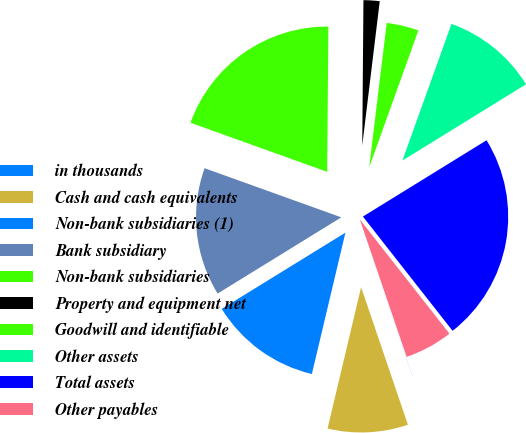Convert chart to OTSL. <chart><loc_0><loc_0><loc_500><loc_500><pie_chart><fcel>in thousands<fcel>Cash and cash equivalents<fcel>Non-bank subsidiaries (1)<fcel>Bank subsidiary<fcel>Non-bank subsidiaries<fcel>Property and equipment net<fcel>Goodwill and identifiable<fcel>Other assets<fcel>Total assets<fcel>Other payables<nl><fcel>0.01%<fcel>8.93%<fcel>12.5%<fcel>14.28%<fcel>19.64%<fcel>1.79%<fcel>3.57%<fcel>10.71%<fcel>23.21%<fcel>5.36%<nl></chart> 